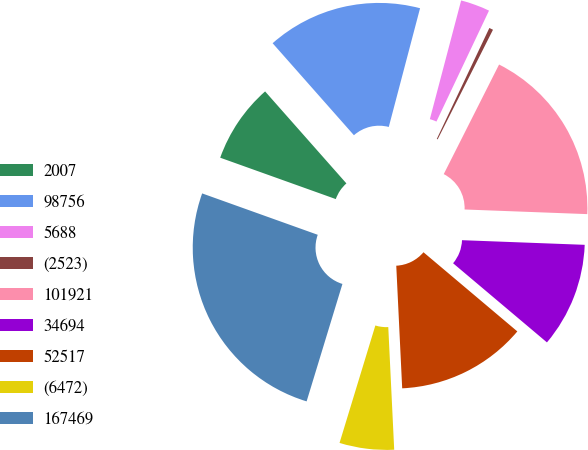<chart> <loc_0><loc_0><loc_500><loc_500><pie_chart><fcel>2007<fcel>98756<fcel>5688<fcel>(2523)<fcel>101921<fcel>34694<fcel>52517<fcel>(6472)<fcel>167469<nl><fcel>8.01%<fcel>15.62%<fcel>2.94%<fcel>0.4%<fcel>18.16%<fcel>10.55%<fcel>13.08%<fcel>5.48%<fcel>25.76%<nl></chart> 